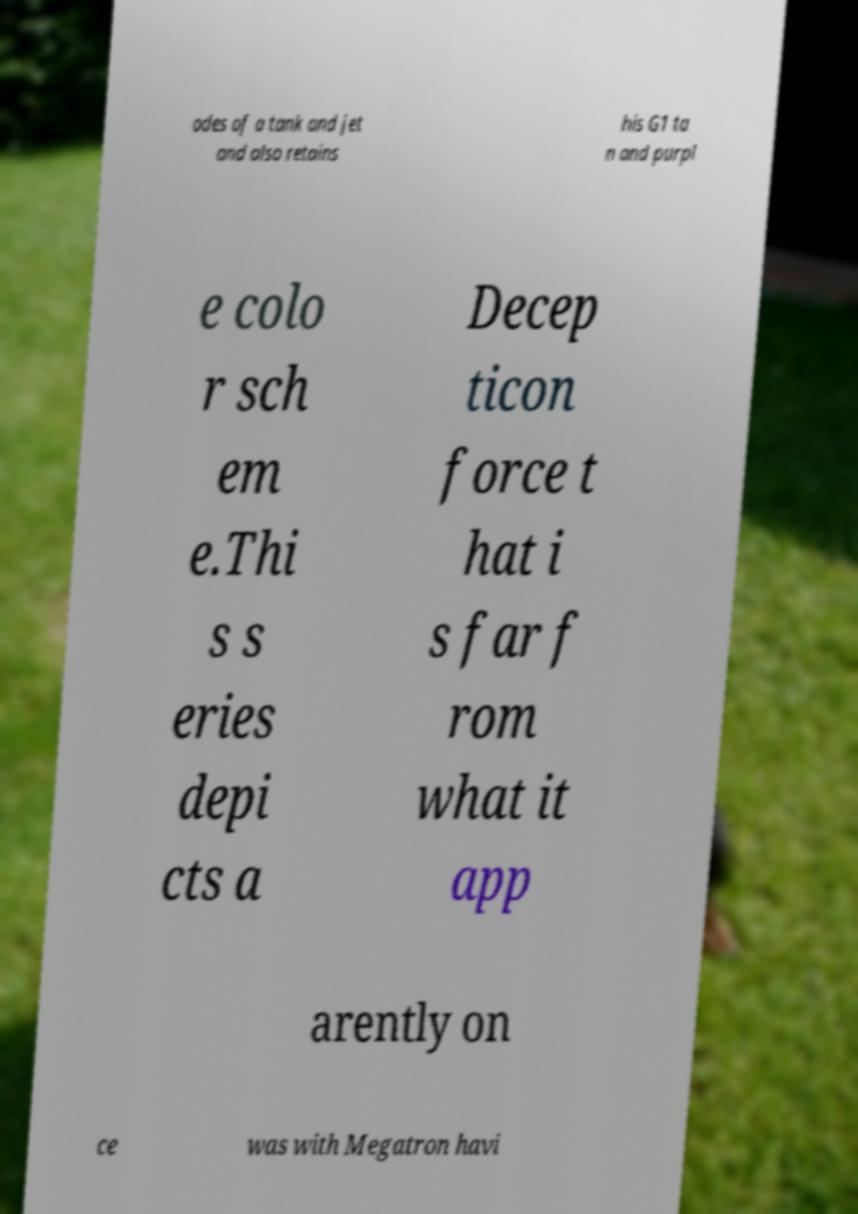Can you read and provide the text displayed in the image?This photo seems to have some interesting text. Can you extract and type it out for me? odes of a tank and jet and also retains his G1 ta n and purpl e colo r sch em e.Thi s s eries depi cts a Decep ticon force t hat i s far f rom what it app arently on ce was with Megatron havi 